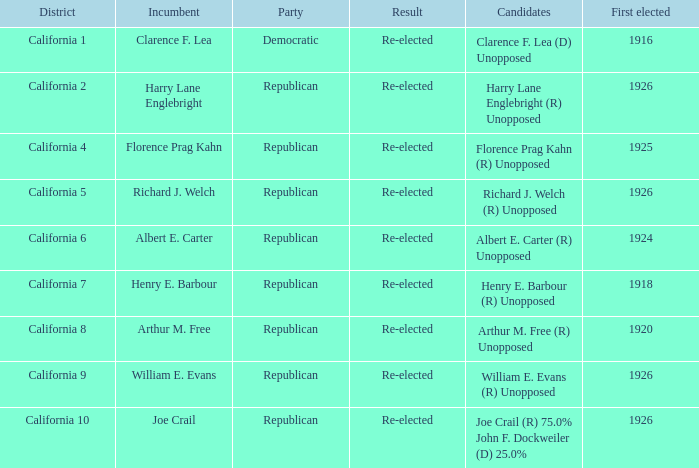What's the districtwith party being democratic California 1. 